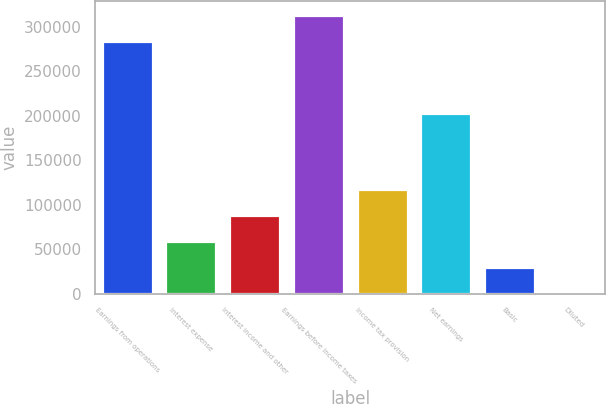Convert chart. <chart><loc_0><loc_0><loc_500><loc_500><bar_chart><fcel>Earnings from operations<fcel>Interest expense<fcel>Interest income and other<fcel>Earnings before income taxes<fcel>Income tax provision<fcel>Net earnings<fcel>Basic<fcel>Diluted<nl><fcel>284491<fcel>58978.4<fcel>88467<fcel>313980<fcel>117956<fcel>203733<fcel>29489.8<fcel>1.28<nl></chart> 